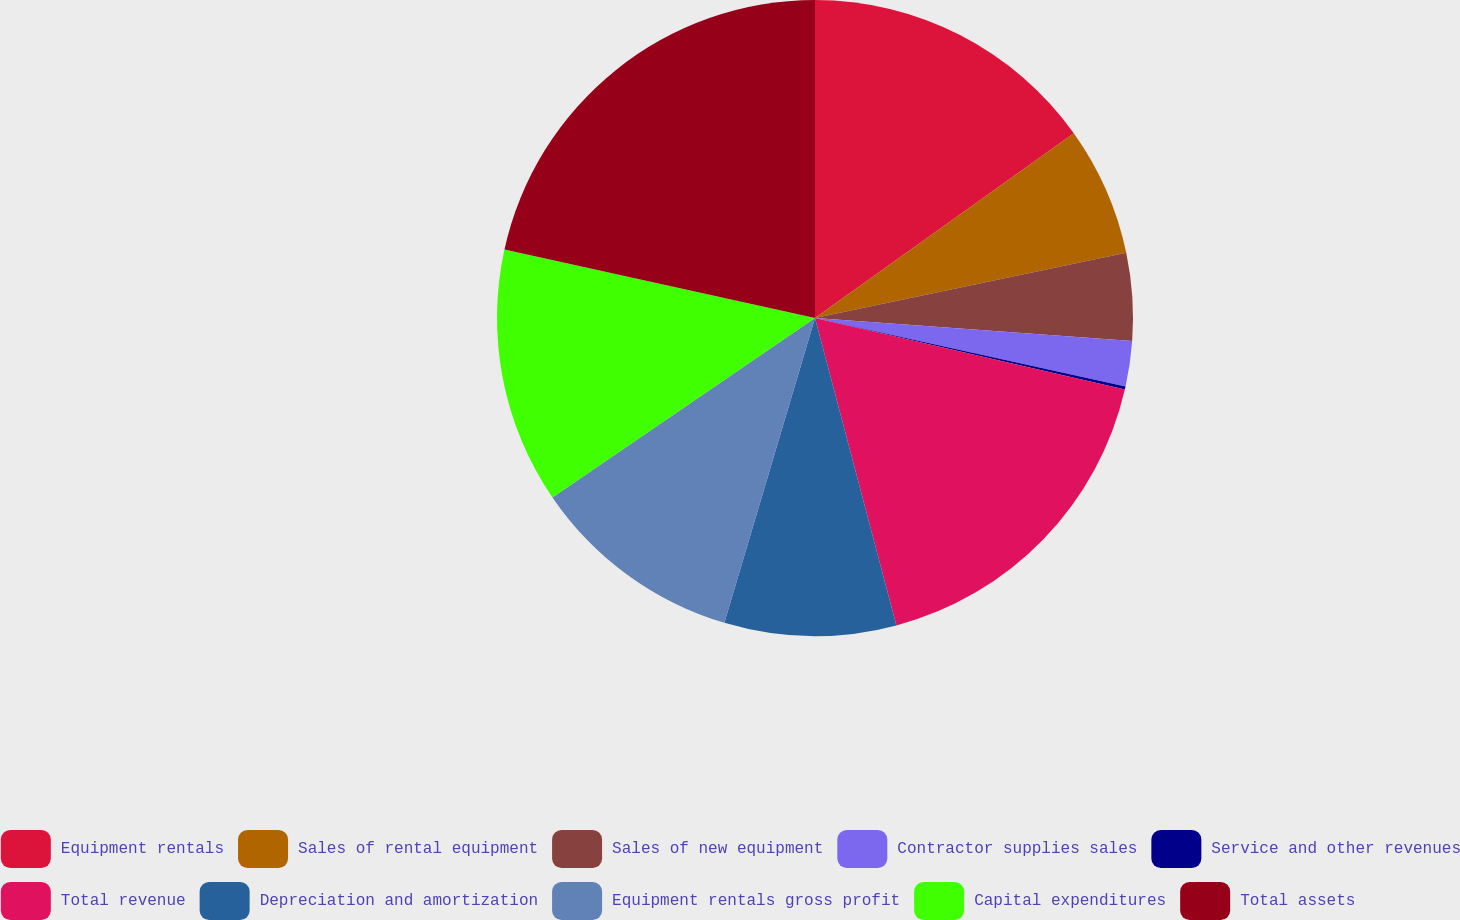Convert chart to OTSL. <chart><loc_0><loc_0><loc_500><loc_500><pie_chart><fcel>Equipment rentals<fcel>Sales of rental equipment<fcel>Sales of new equipment<fcel>Contractor supplies sales<fcel>Service and other revenues<fcel>Total revenue<fcel>Depreciation and amortization<fcel>Equipment rentals gross profit<fcel>Capital expenditures<fcel>Total assets<nl><fcel>15.13%<fcel>6.58%<fcel>4.44%<fcel>2.3%<fcel>0.16%<fcel>17.27%<fcel>8.72%<fcel>10.86%<fcel>12.99%<fcel>21.55%<nl></chart> 